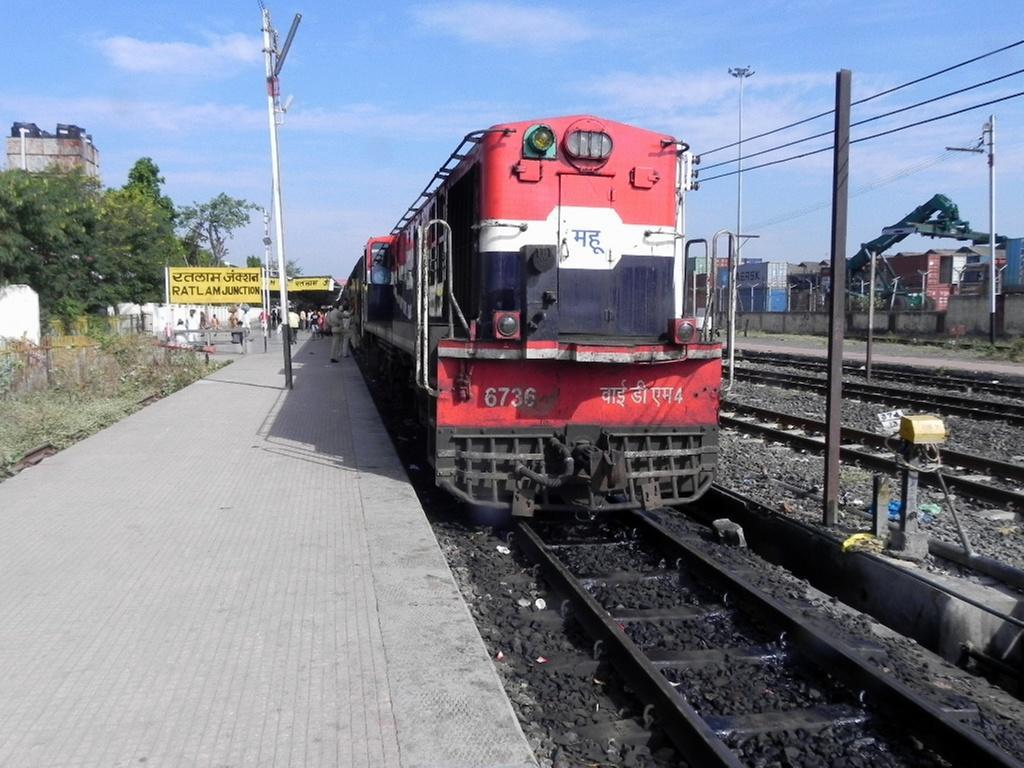Could you give a brief overview of what you see in this image? In this picture I can see the tracks and on the left track I can see a train and on the left side of this image I see the platform, on which there are number of people. In the middle of this picture I see few trees, boards on which there is something written, number of poles, wires and I see the plants. In the background I see the clear sky. 